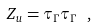<formula> <loc_0><loc_0><loc_500><loc_500>\label l { e q \colon p a r t f u n a g a i n } Z _ { u } = \tau _ { \Gamma } \tau _ { \Gamma } \ ,</formula> 